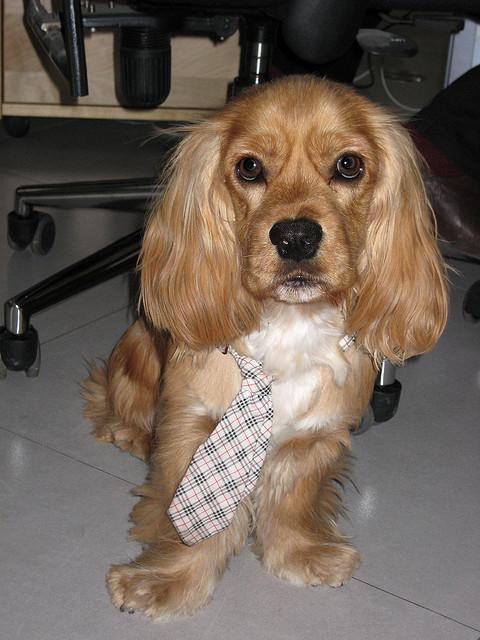How many puppies?
Give a very brief answer. 1. 